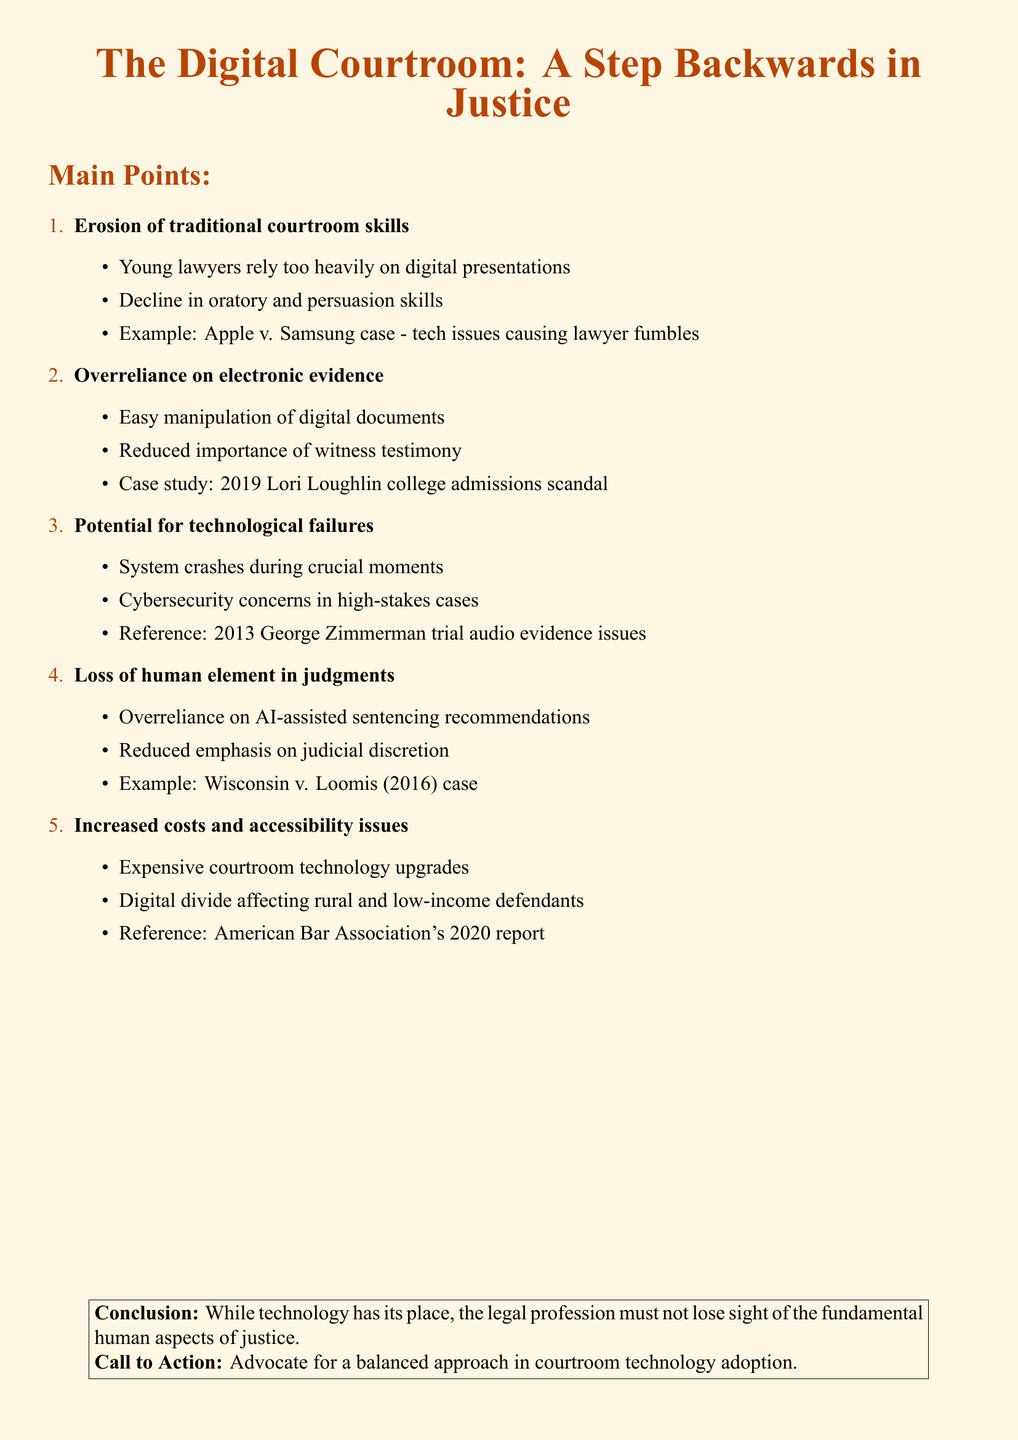What is the title of the op-ed piece? The title is explicitly stated in the document as the main heading.
Answer: The Digital Courtroom: A Step Backwards in Justice What is one example of a case mentioned regarding digital presentations? The document references specific cases to illustrate points, including a high-profile case involving technology issues.
Answer: Apple v. Samsung In which case was email evidence crucial? The document provides a case study to show the overreliance on electronic evidence, highlighting specific incidents.
Answer: 2019 Lori Loughlin college admissions scandal What year was the George Zimmerman trial? The document references a specific year related to the technological failures that occurred during a trial.
Answer: 2013 What does the conclusion emphasize about technology in the legal profession? The conclusion provides a summary that reflects the overall stance of the document regarding the role of technology.
Answer: Fundamental human aspects of justice What is a significant issue mentioned regarding costs? The document discusses specific challenges and financial implications related to technology in courtrooms.
Answer: Expensive courtroom technology upgrades What should be advocated for according to the call to action? The document ends with a specific suggestion for actions that should be taken in response to the points discussed.
Answer: Balanced approach in courtroom technology adoption What is one skill that young lawyers are losing according to the document? The document highlights the decline in specific skills among younger lawyers related to courtroom practices.
Answer: Oratory skills What problem does the digital divide create according to the document? The document discusses the impact of technology disparities on certain demographics within the legal system.
Answer: Accessibility issues 